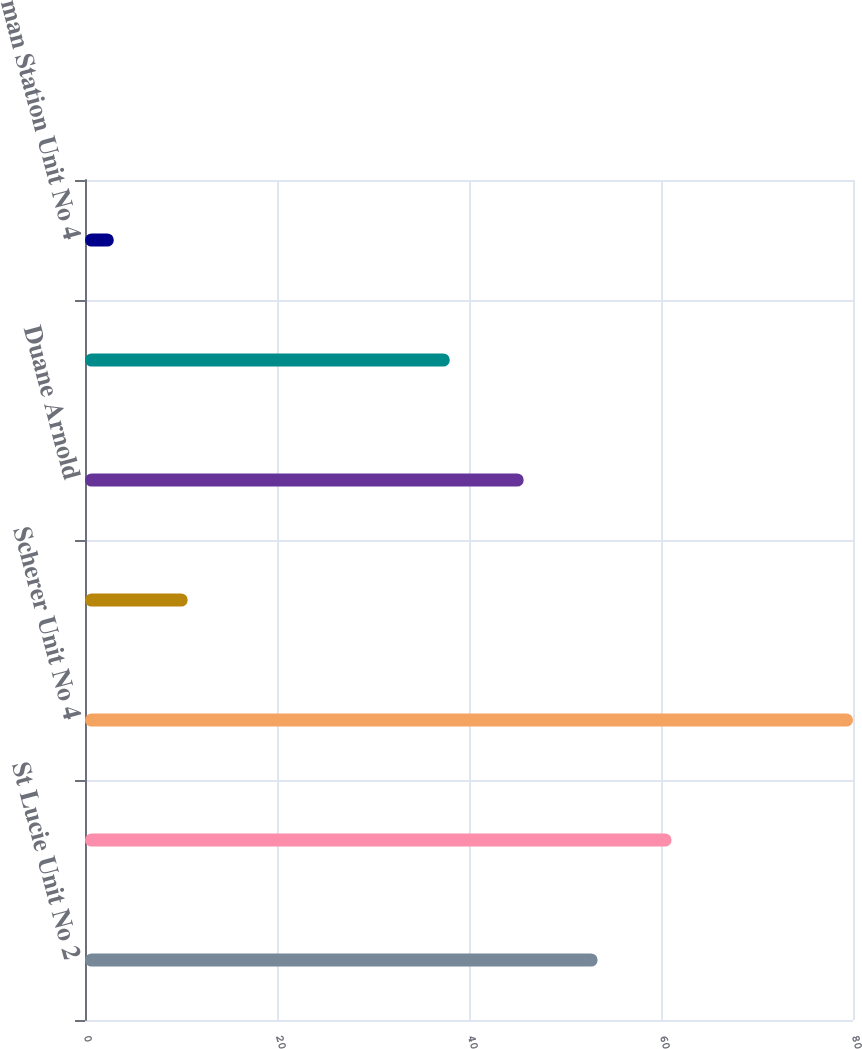Convert chart. <chart><loc_0><loc_0><loc_500><loc_500><bar_chart><fcel>St Lucie Unit No 2<fcel>St Johns River Power Park<fcel>Scherer Unit No 4<fcel>Transmission substation assets<fcel>Duane Arnold<fcel>Seabrook<fcel>Wyman Station Unit No 4<nl><fcel>53.4<fcel>61.1<fcel>80<fcel>10.7<fcel>45.7<fcel>38<fcel>3<nl></chart> 